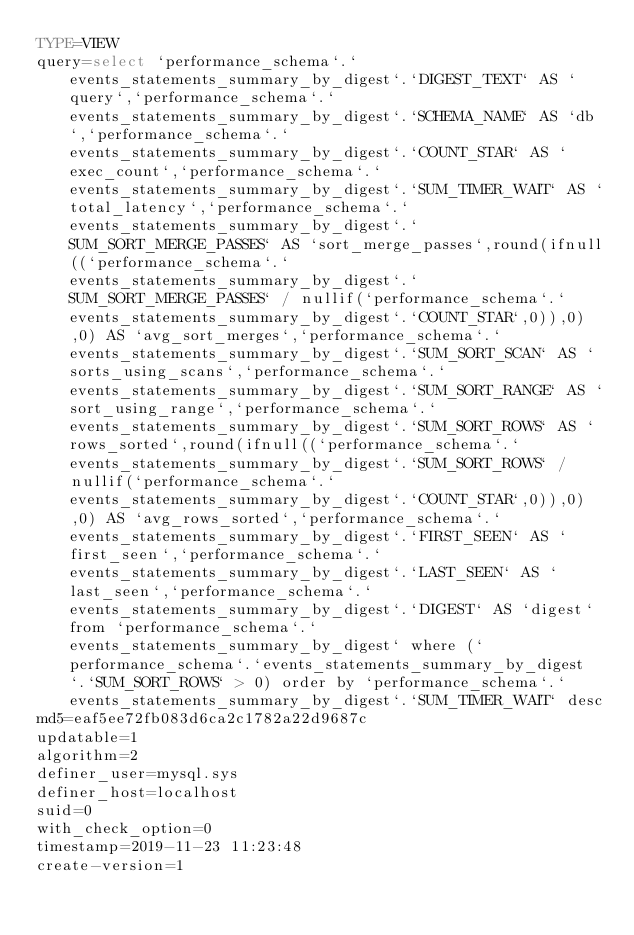Convert code to text. <code><loc_0><loc_0><loc_500><loc_500><_VisualBasic_>TYPE=VIEW
query=select `performance_schema`.`events_statements_summary_by_digest`.`DIGEST_TEXT` AS `query`,`performance_schema`.`events_statements_summary_by_digest`.`SCHEMA_NAME` AS `db`,`performance_schema`.`events_statements_summary_by_digest`.`COUNT_STAR` AS `exec_count`,`performance_schema`.`events_statements_summary_by_digest`.`SUM_TIMER_WAIT` AS `total_latency`,`performance_schema`.`events_statements_summary_by_digest`.`SUM_SORT_MERGE_PASSES` AS `sort_merge_passes`,round(ifnull((`performance_schema`.`events_statements_summary_by_digest`.`SUM_SORT_MERGE_PASSES` / nullif(`performance_schema`.`events_statements_summary_by_digest`.`COUNT_STAR`,0)),0),0) AS `avg_sort_merges`,`performance_schema`.`events_statements_summary_by_digest`.`SUM_SORT_SCAN` AS `sorts_using_scans`,`performance_schema`.`events_statements_summary_by_digest`.`SUM_SORT_RANGE` AS `sort_using_range`,`performance_schema`.`events_statements_summary_by_digest`.`SUM_SORT_ROWS` AS `rows_sorted`,round(ifnull((`performance_schema`.`events_statements_summary_by_digest`.`SUM_SORT_ROWS` / nullif(`performance_schema`.`events_statements_summary_by_digest`.`COUNT_STAR`,0)),0),0) AS `avg_rows_sorted`,`performance_schema`.`events_statements_summary_by_digest`.`FIRST_SEEN` AS `first_seen`,`performance_schema`.`events_statements_summary_by_digest`.`LAST_SEEN` AS `last_seen`,`performance_schema`.`events_statements_summary_by_digest`.`DIGEST` AS `digest` from `performance_schema`.`events_statements_summary_by_digest` where (`performance_schema`.`events_statements_summary_by_digest`.`SUM_SORT_ROWS` > 0) order by `performance_schema`.`events_statements_summary_by_digest`.`SUM_TIMER_WAIT` desc
md5=eaf5ee72fb083d6ca2c1782a22d9687c
updatable=1
algorithm=2
definer_user=mysql.sys
definer_host=localhost
suid=0
with_check_option=0
timestamp=2019-11-23 11:23:48
create-version=1</code> 